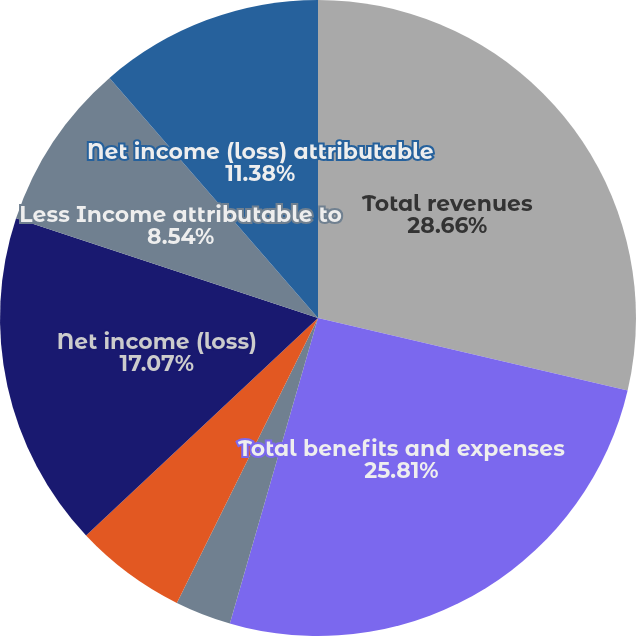Convert chart. <chart><loc_0><loc_0><loc_500><loc_500><pie_chart><fcel>Total revenues<fcel>Total benefits and expenses<fcel>Income (loss) from continuing<fcel>Income (loss) from<fcel>Net income (loss)<fcel>Less Income attributable to<fcel>Net income (loss) attributable<nl><fcel>28.66%<fcel>25.81%<fcel>2.85%<fcel>5.69%<fcel>17.07%<fcel>8.54%<fcel>11.38%<nl></chart> 